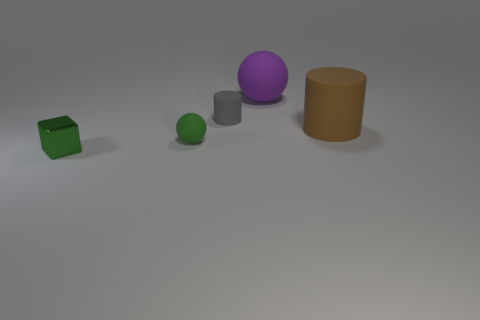Add 1 brown objects. How many objects exist? 6 Subtract all balls. How many objects are left? 3 Add 4 big yellow matte blocks. How many big yellow matte blocks exist? 4 Subtract 0 gray balls. How many objects are left? 5 Subtract all large purple cubes. Subtract all small green balls. How many objects are left? 4 Add 4 big rubber objects. How many big rubber objects are left? 6 